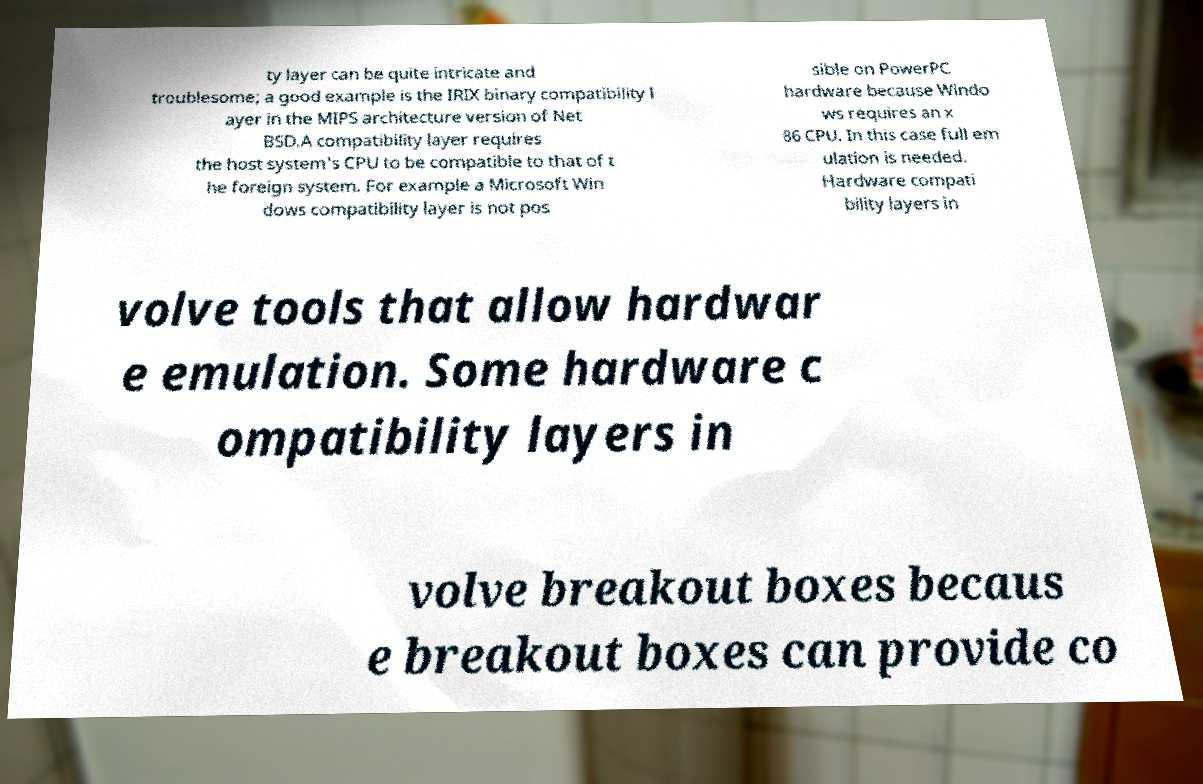Can you accurately transcribe the text from the provided image for me? ty layer can be quite intricate and troublesome; a good example is the IRIX binary compatibility l ayer in the MIPS architecture version of Net BSD.A compatibility layer requires the host system's CPU to be compatible to that of t he foreign system. For example a Microsoft Win dows compatibility layer is not pos sible on PowerPC hardware because Windo ws requires an x 86 CPU. In this case full em ulation is needed. Hardware compati bility layers in volve tools that allow hardwar e emulation. Some hardware c ompatibility layers in volve breakout boxes becaus e breakout boxes can provide co 